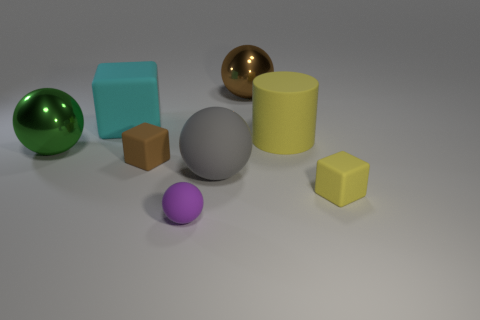How big is the thing that is both on the left side of the gray ball and to the right of the tiny brown object?
Your answer should be very brief. Small. There is a brown object that is the same material as the large green object; what size is it?
Give a very brief answer. Large. How many things are either large objects that are behind the big gray object or large green shiny objects on the left side of the large rubber cylinder?
Keep it short and to the point. 4. Does the shiny sphere that is to the right of the brown matte thing have the same size as the big green shiny ball?
Make the answer very short. Yes. What color is the metal thing in front of the big brown thing?
Keep it short and to the point. Green. The other matte object that is the same shape as the purple rubber object is what color?
Provide a succinct answer. Gray. There is a shiny thing that is left of the large metal thing that is behind the large yellow matte thing; what number of balls are right of it?
Offer a very short reply. 3. Are there fewer things to the left of the tiny ball than small brown objects?
Your answer should be compact. No. There is a brown rubber thing that is the same shape as the small yellow object; what size is it?
Make the answer very short. Small. What number of big cyan blocks are made of the same material as the tiny yellow object?
Ensure brevity in your answer.  1. 